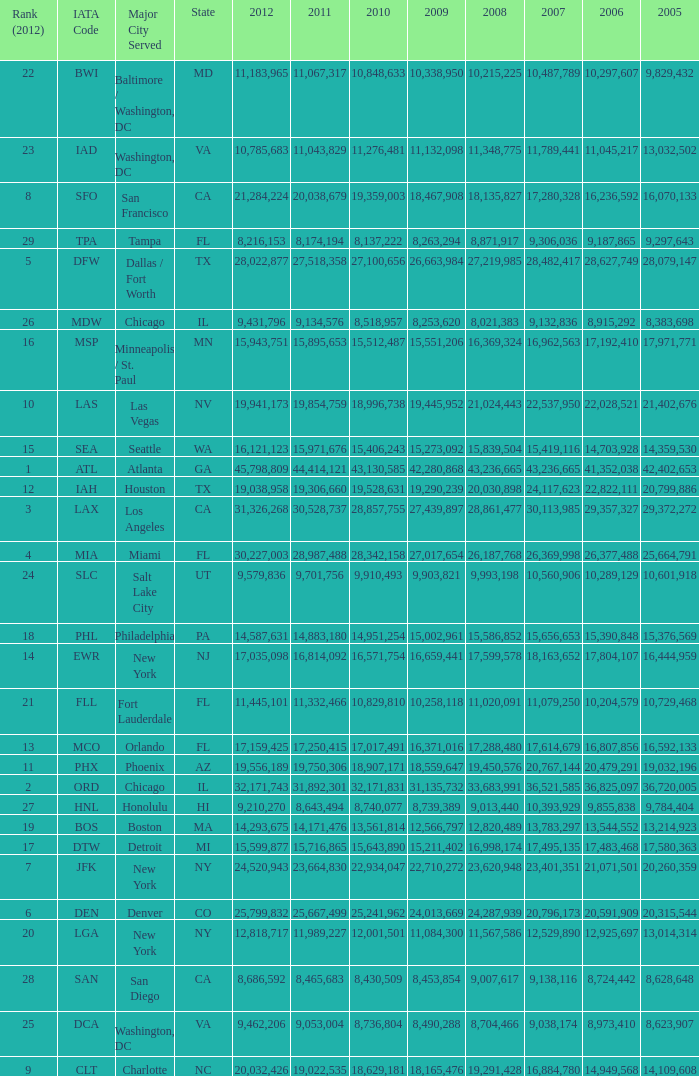When Philadelphia has a 2007 less than 20,796,173 and a 2008 more than 10,215,225, what is the smallest 2009? 15002961.0. 